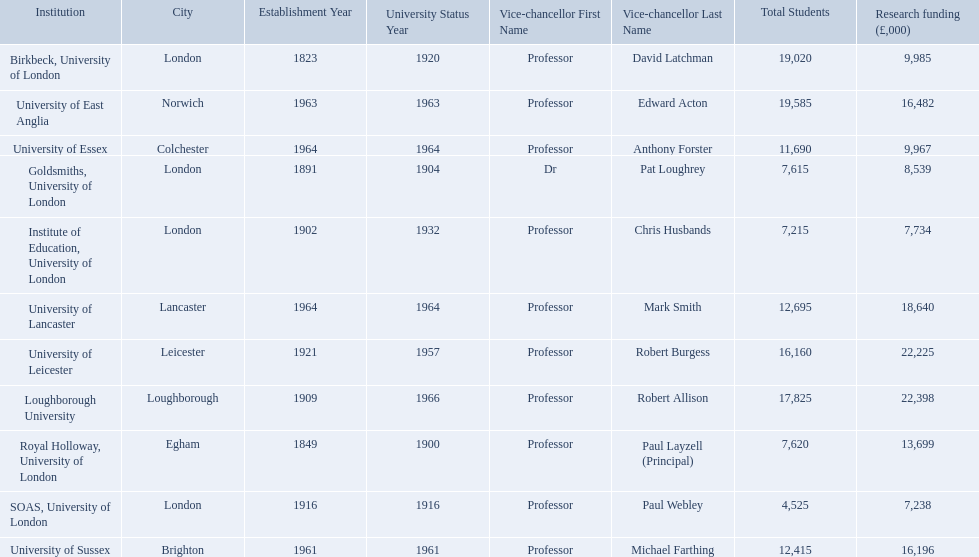What are the institutions in the 1994 group? Birkbeck, University of London, University of East Anglia, University of Essex, Goldsmiths, University of London, Institute of Education, University of London, University of Lancaster, University of Leicester, Loughborough University, Royal Holloway, University of London, SOAS, University of London, University of Sussex. Which of these was made a university most recently? Loughborough University. What are the names of all the institutions? Birkbeck, University of London, University of East Anglia, University of Essex, Goldsmiths, University of London, Institute of Education, University of London, University of Lancaster, University of Leicester, Loughborough University, Royal Holloway, University of London, SOAS, University of London, University of Sussex. In what range of years were these institutions established? 1823, 1963, 1964, 1891, 1902, 1964, 1921, 1909, 1849, 1916, 1961. In what range of years did these institutions gain university status? 1920, 1963, 1964, 1904, 1932, 1964, 1957, 1966, 1900, 1916, 1961. What institution most recently gained university status? Loughborough University. 